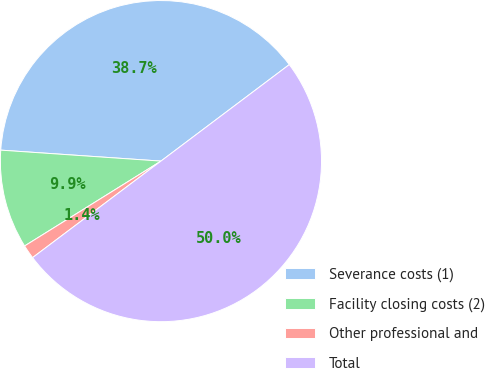Convert chart. <chart><loc_0><loc_0><loc_500><loc_500><pie_chart><fcel>Severance costs (1)<fcel>Facility closing costs (2)<fcel>Other professional and<fcel>Total<nl><fcel>38.65%<fcel>9.95%<fcel>1.4%<fcel>50.0%<nl></chart> 